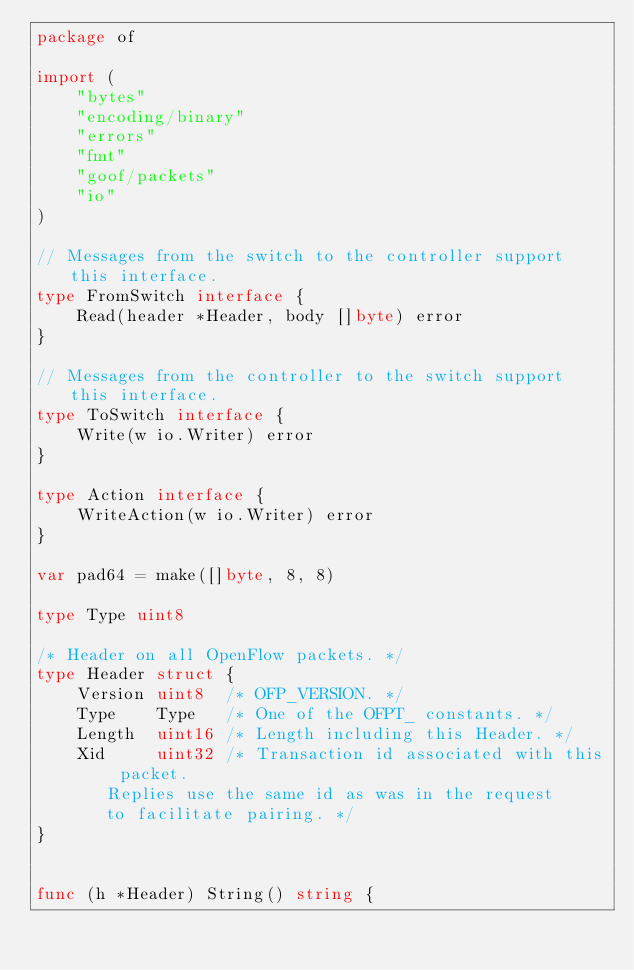Convert code to text. <code><loc_0><loc_0><loc_500><loc_500><_Go_>package of

import (
	"bytes"
	"encoding/binary"
	"errors"
	"fmt"
	"goof/packets"
	"io"
)

// Messages from the switch to the controller support this interface.
type FromSwitch interface {
	Read(header *Header, body []byte) error
}

// Messages from the controller to the switch support this interface.
type ToSwitch interface {
	Write(w io.Writer) error
}

type Action interface {
	WriteAction(w io.Writer) error
}

var pad64 = make([]byte, 8, 8)

type Type uint8

/* Header on all OpenFlow packets. */
type Header struct {
	Version uint8  /* OFP_VERSION. */
	Type    Type   /* One of the OFPT_ constants. */
	Length  uint16 /* Length including this Header. */
	Xid     uint32 /* Transaction id associated with this packet.
	   Replies use the same id as was in the request
	   to facilitate pairing. */
}


func (h *Header) String() string {</code> 